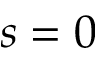<formula> <loc_0><loc_0><loc_500><loc_500>s = 0</formula> 